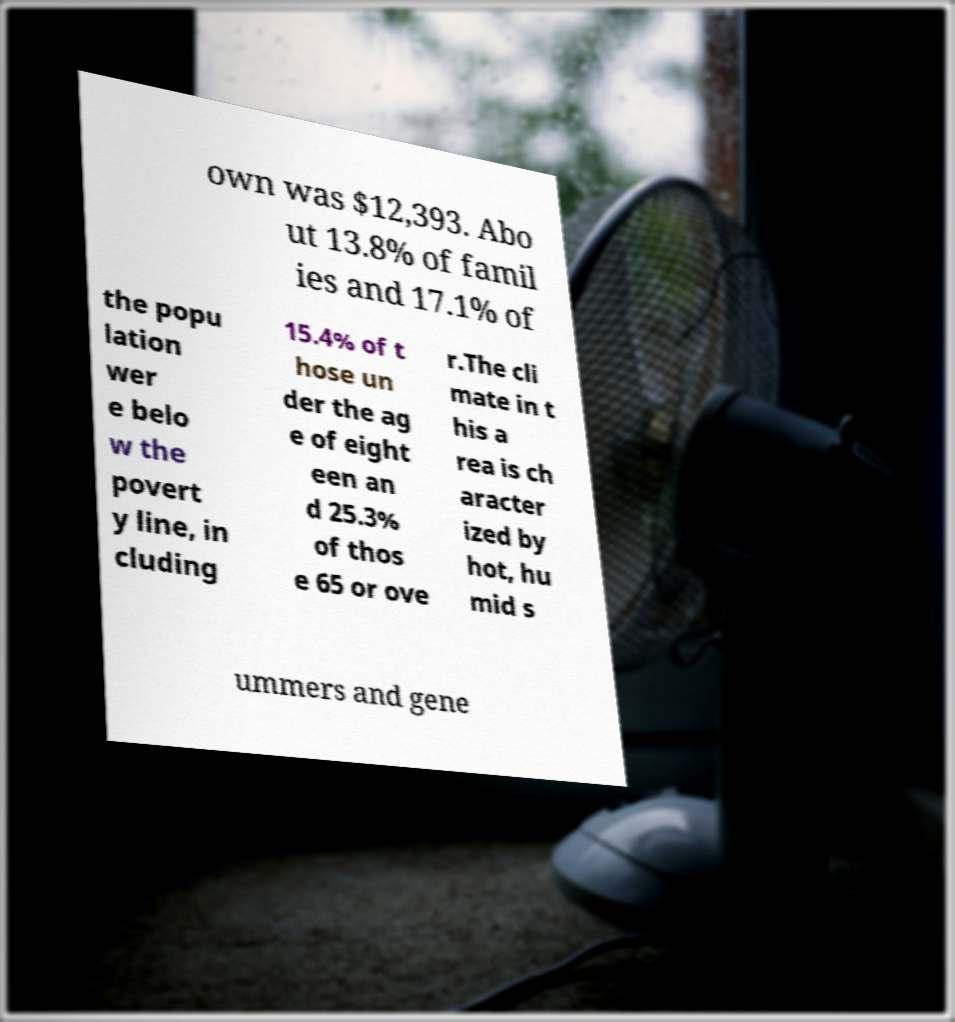Could you extract and type out the text from this image? own was $12,393. Abo ut 13.8% of famil ies and 17.1% of the popu lation wer e belo w the povert y line, in cluding 15.4% of t hose un der the ag e of eight een an d 25.3% of thos e 65 or ove r.The cli mate in t his a rea is ch aracter ized by hot, hu mid s ummers and gene 